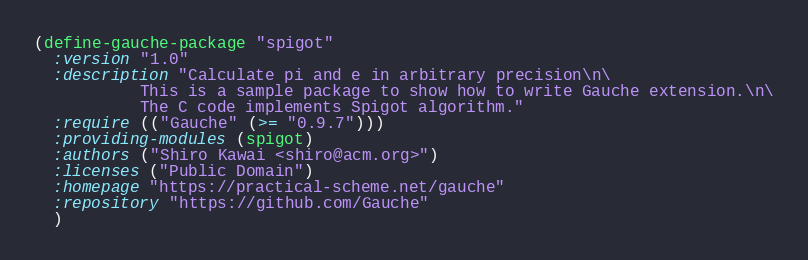<code> <loc_0><loc_0><loc_500><loc_500><_Scheme_>(define-gauche-package "spigot"
  :version "1.0"
  :description "Calculate pi and e in arbitrary precision\n\
           This is a sample package to show how to write Gauche extension.\n\
           The C code implements Spigot algorithm."
  :require (("Gauche" (>= "0.9.7")))
  :providing-modules (spigot)
  :authors ("Shiro Kawai <shiro@acm.org>")
  :licenses ("Public Domain")
  :homepage "https://practical-scheme.net/gauche"
  :repository "https://github.com/Gauche"
  )
</code> 